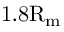<formula> <loc_0><loc_0><loc_500><loc_500>1 . 8 R _ { m }</formula> 